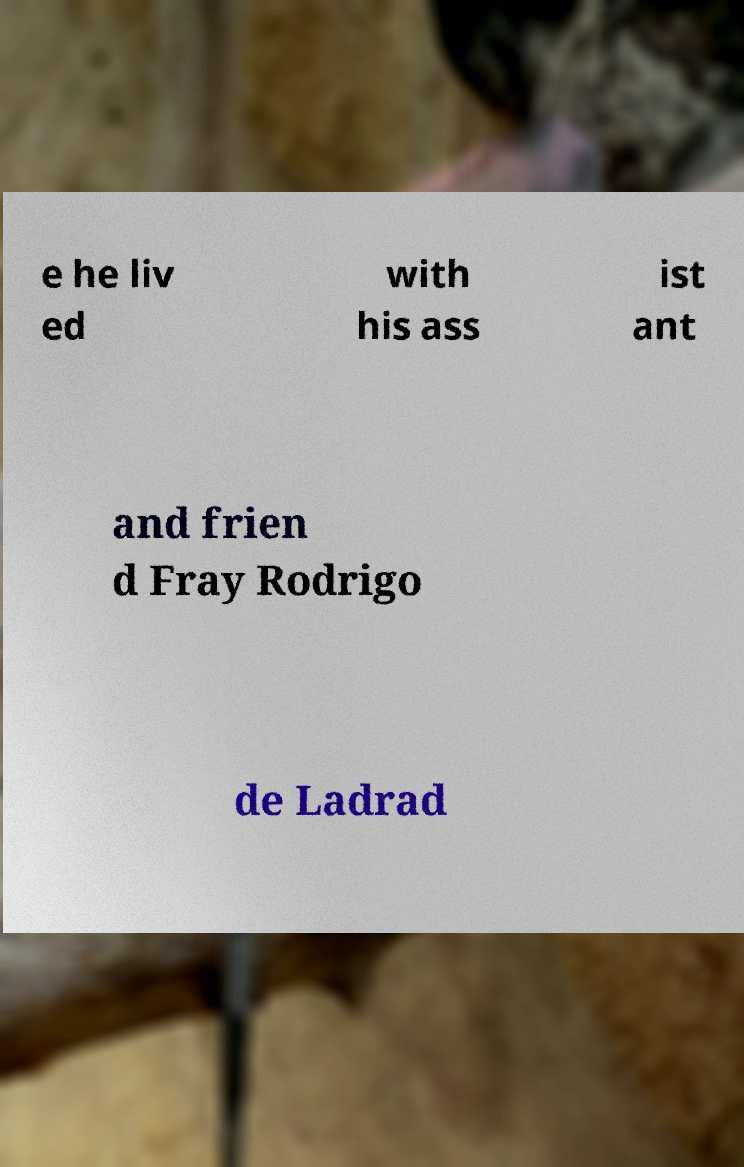Could you extract and type out the text from this image? e he liv ed with his ass ist ant and frien d Fray Rodrigo de Ladrad 